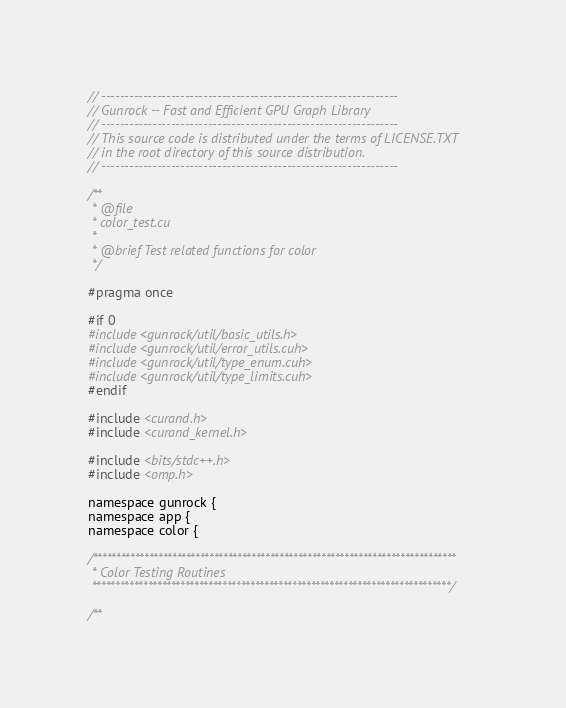Convert code to text. <code><loc_0><loc_0><loc_500><loc_500><_Cuda_>// ----------------------------------------------------------------
// Gunrock -- Fast and Efficient GPU Graph Library
// ----------------------------------------------------------------
// This source code is distributed under the terms of LICENSE.TXT
// in the root directory of this source distribution.
// ----------------------------------------------------------------

/**
 * @file
 * color_test.cu
 *
 * @brief Test related functions for color
 */

#pragma once

#if 0
#include <gunrock/util/basic_utils.h>
#include <gunrock/util/error_utils.cuh>
#include <gunrock/util/type_enum.cuh>
#include <gunrock/util/type_limits.cuh>
#endif

#include <curand.h>
#include <curand_kernel.h>

#include <bits/stdc++.h>
#include <omp.h>

namespace gunrock {
namespace app {
namespace color {

/******************************************************************************
 * Color Testing Routines
 *****************************************************************************/

/**</code> 